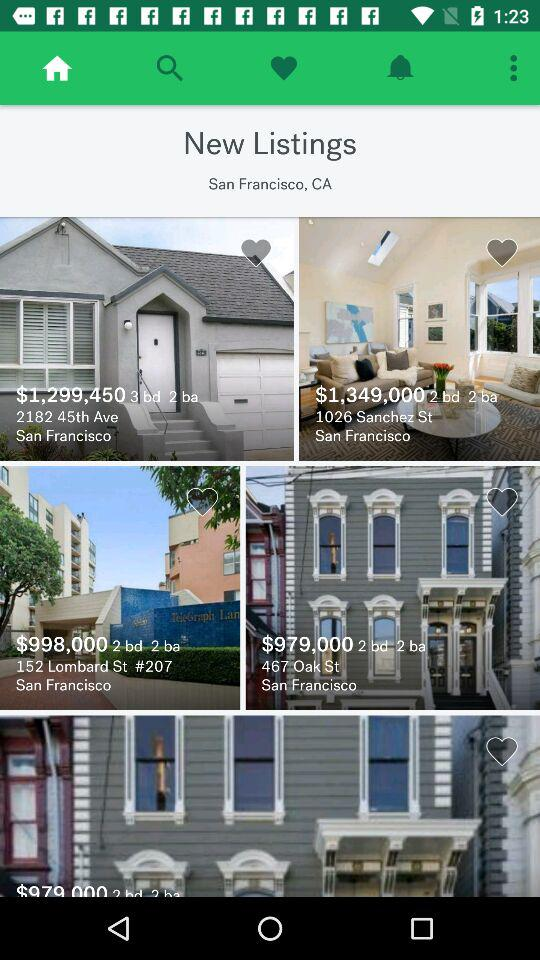What is the address of the house whose price is $979,000? The address of the house is "467 Oak St, San Francisco". 